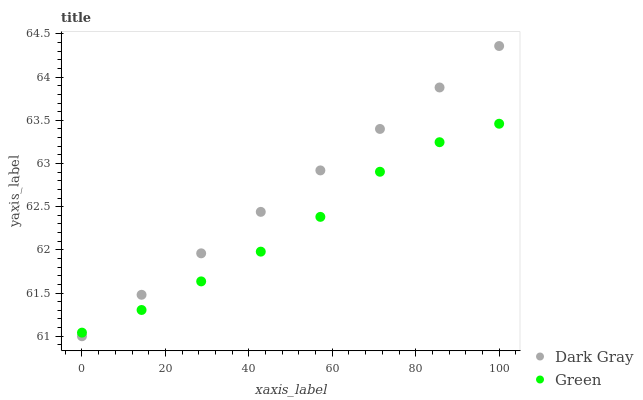Does Green have the minimum area under the curve?
Answer yes or no. Yes. Does Dark Gray have the maximum area under the curve?
Answer yes or no. Yes. Does Green have the maximum area under the curve?
Answer yes or no. No. Is Dark Gray the smoothest?
Answer yes or no. Yes. Is Green the roughest?
Answer yes or no. Yes. Is Green the smoothest?
Answer yes or no. No. Does Dark Gray have the lowest value?
Answer yes or no. Yes. Does Green have the lowest value?
Answer yes or no. No. Does Dark Gray have the highest value?
Answer yes or no. Yes. Does Green have the highest value?
Answer yes or no. No. Does Dark Gray intersect Green?
Answer yes or no. Yes. Is Dark Gray less than Green?
Answer yes or no. No. Is Dark Gray greater than Green?
Answer yes or no. No. 